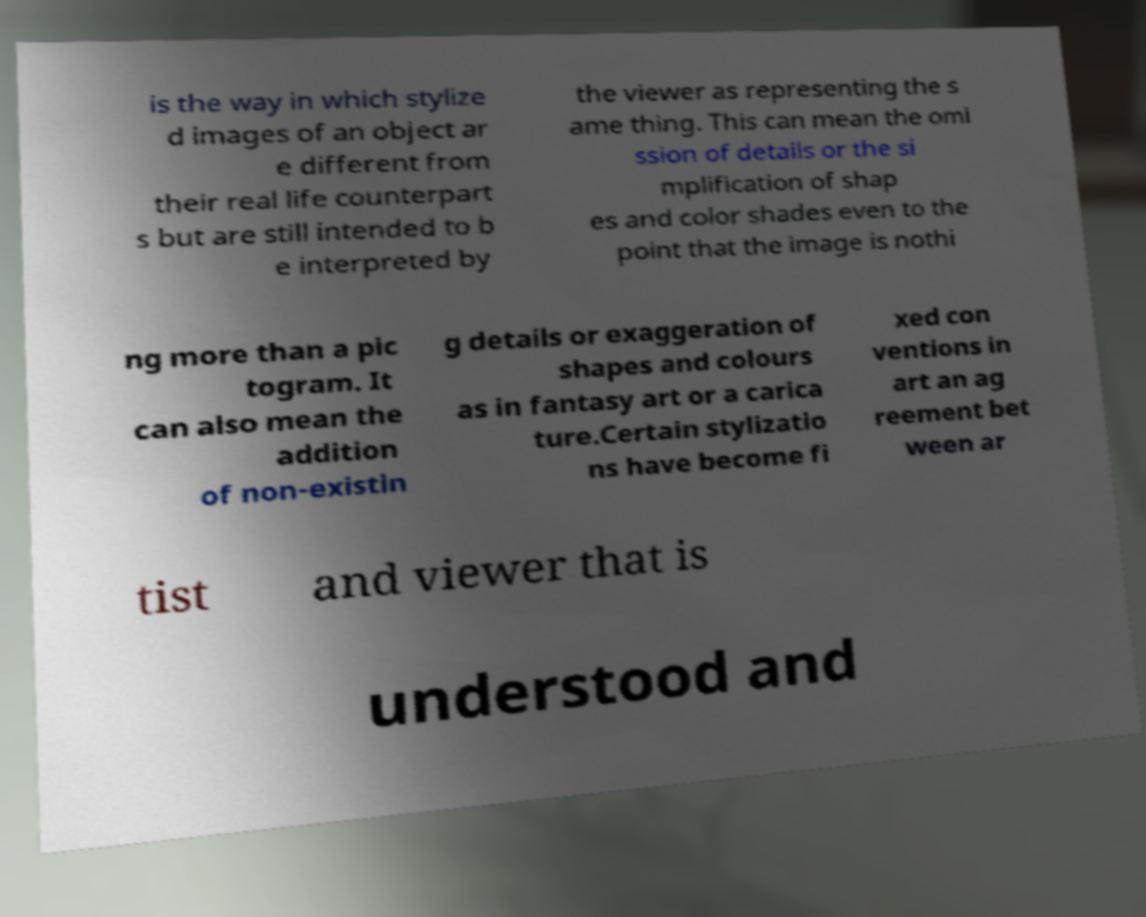I need the written content from this picture converted into text. Can you do that? is the way in which stylize d images of an object ar e different from their real life counterpart s but are still intended to b e interpreted by the viewer as representing the s ame thing. This can mean the omi ssion of details or the si mplification of shap es and color shades even to the point that the image is nothi ng more than a pic togram. It can also mean the addition of non-existin g details or exaggeration of shapes and colours as in fantasy art or a carica ture.Certain stylizatio ns have become fi xed con ventions in art an ag reement bet ween ar tist and viewer that is understood and 